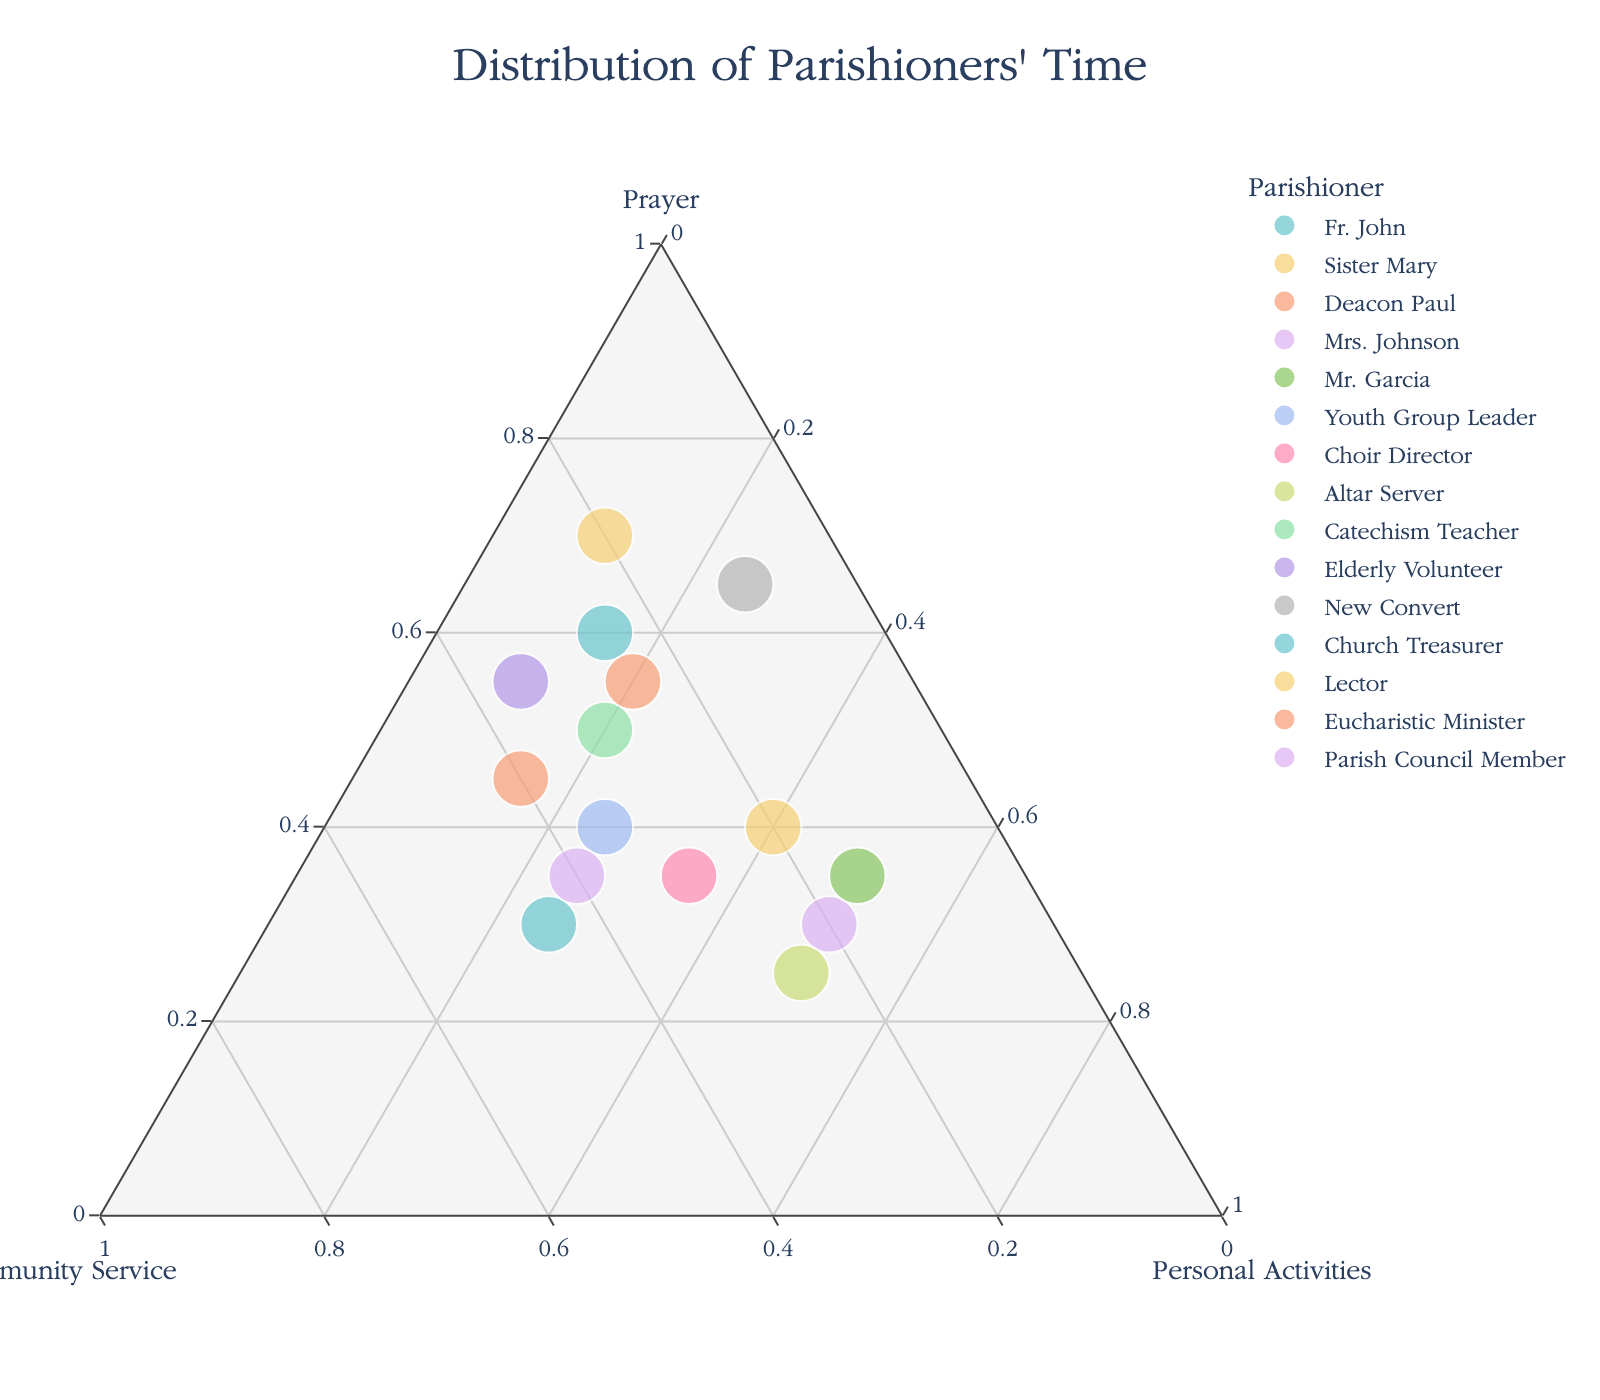What's the title of the plot? The plot title is displayed at the top center and provides context about the data being visualized. Examining closely, it reads "Distribution of Parishioners' Time."
Answer: Distribution of Parishioners' Time How many parishioners are represented in the plot? Each data point on the plot represents a parishioner, and we can count the number of unique data points or labels corresponding to each parishioner. There are 15 such distinct points.
Answer: 15 Which parishioner spends the highest proportion of their time on prayer? By looking at the plot's "Prayer" axis (one of the ternary plot axes), the data point furthest towards the Prayer corner indicates the highest proportion. This corresponds to Sister Mary.
Answer: Sister Mary Who spends an equal amount of time on community service and personal activities? The midline between Community Service and Personal Activities in the ternary plot is where we should find the individual. The data point for Mr. Garcia shows him having similar proportions for these activities.
Answer: Mr. Garcia Which parishioner spends the least amount of time on personal activities? The parishioner whose data point is furthest from the Personal Activities corner is the one with the smallest proportion. This is Sister Mary.
Answer: Sister Mary Calculate the average percentage of time spent on prayer across all parishioners. Sum the percentages spent on prayer and divide by the number of parishioners: (60 + 70 + 45 + 30 + 35 + 40 + 35 + 25 + 50 + 55 + 65 + 30 + 40 + 55 + 35) / 15 ≈ 44.67%
Answer: 44.67% Compare the time spent on community service by Fr. John and the Church Treasurer; who spends more time? Locate Fr. John's and the Church Treasurer's data points and compare their positions along the Community Service axis. The Church Treasurer spends more time (45% vs. 25%).
Answer: The Church Treasurer Which parishioner's time distribution is almost perfectly balanced among the three activities? Look for a data point near the center of the plot where all three proportions are nearly equal. Choir Director's distribution is 35% prayer, 30% community service, and 35% personal activities, which is quite balanced.
Answer: Choir Director What is the common color scheme used to represent different parishioners? Observing the plot, different colors from a pastel color palette are assigned to various parishioners to differentiate between them. This is based on the "color_discrete_sequence" parameter in the visualization code.
Answer: Pastel colors 